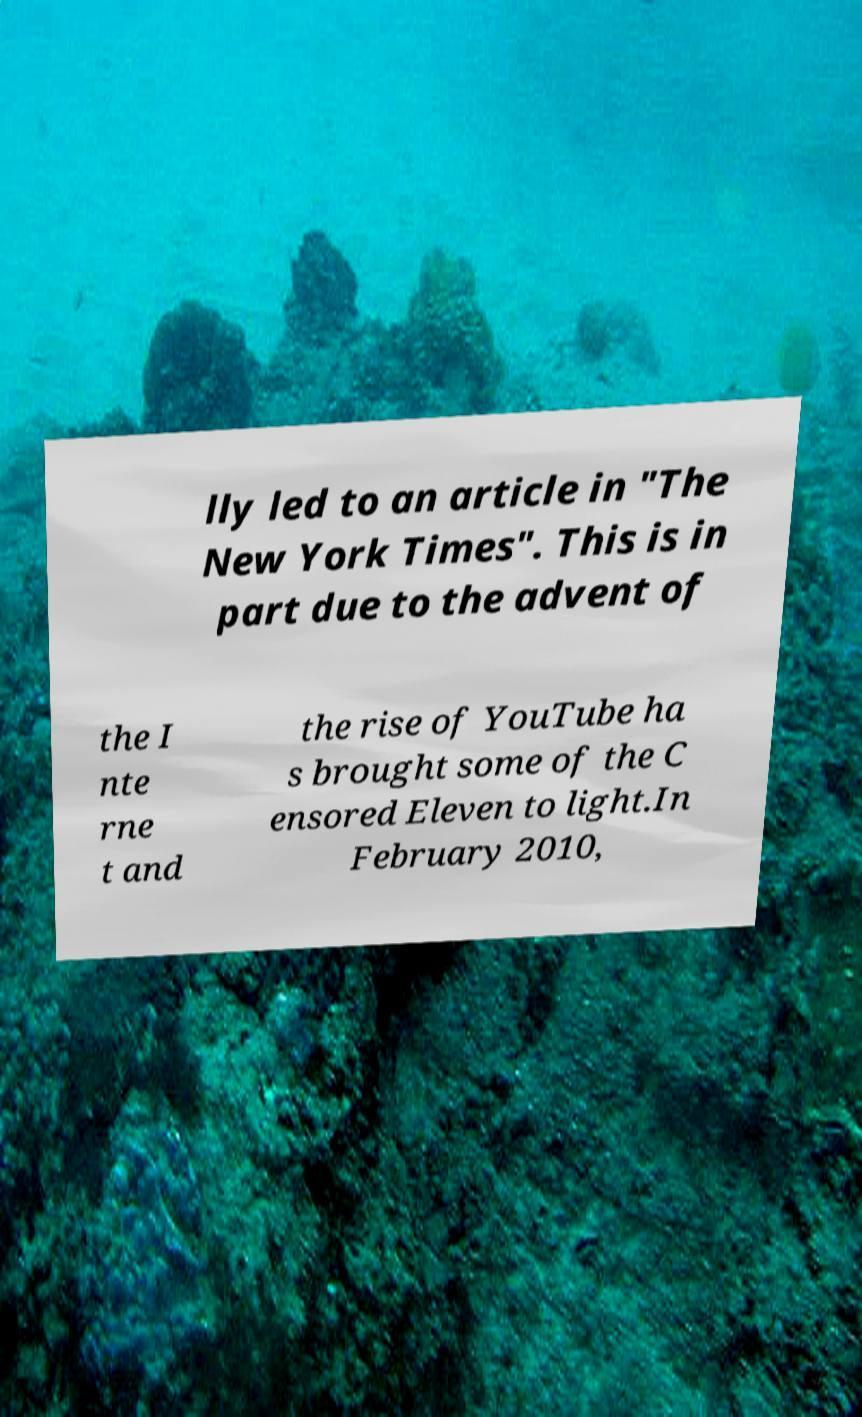There's text embedded in this image that I need extracted. Can you transcribe it verbatim? lly led to an article in "The New York Times". This is in part due to the advent of the I nte rne t and the rise of YouTube ha s brought some of the C ensored Eleven to light.In February 2010, 